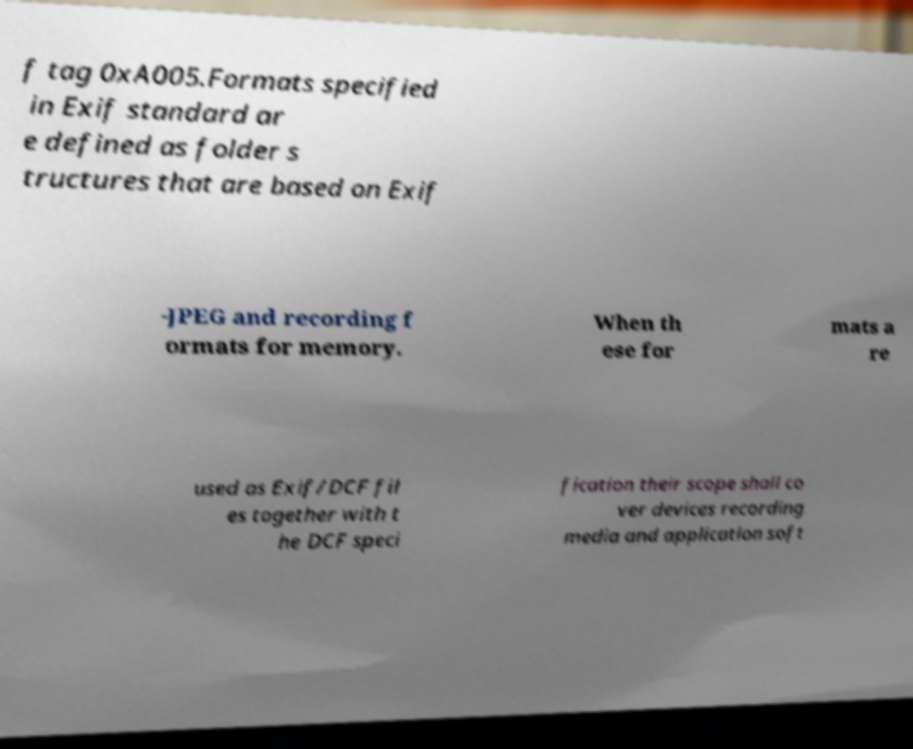There's text embedded in this image that I need extracted. Can you transcribe it verbatim? f tag 0xA005.Formats specified in Exif standard ar e defined as folder s tructures that are based on Exif -JPEG and recording f ormats for memory. When th ese for mats a re used as Exif/DCF fil es together with t he DCF speci fication their scope shall co ver devices recording media and application soft 